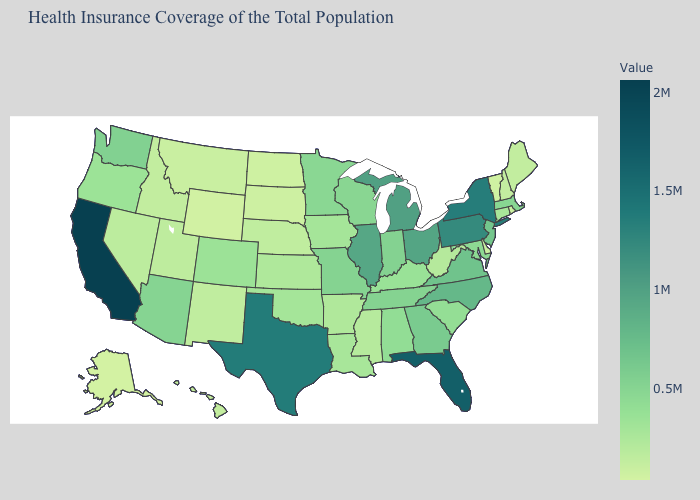Which states hav the highest value in the West?
Write a very short answer. California. Among the states that border California , does Arizona have the highest value?
Keep it brief. Yes. Which states hav the highest value in the MidWest?
Write a very short answer. Michigan. Does New Hampshire have the lowest value in the Northeast?
Short answer required. No. Among the states that border Idaho , which have the highest value?
Be succinct. Washington. 